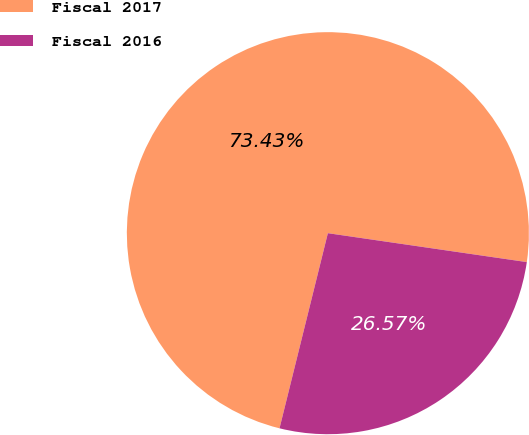Convert chart. <chart><loc_0><loc_0><loc_500><loc_500><pie_chart><fcel>Fiscal 2017<fcel>Fiscal 2016<nl><fcel>73.43%<fcel>26.57%<nl></chart> 